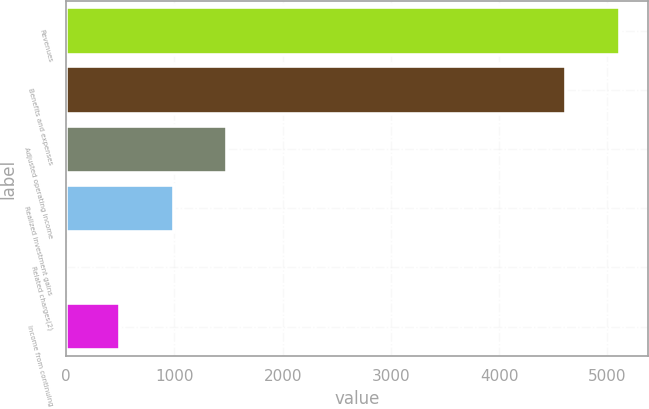Convert chart to OTSL. <chart><loc_0><loc_0><loc_500><loc_500><bar_chart><fcel>Revenues<fcel>Benefits and expenses<fcel>Adjusted operating income<fcel>Realized investment gains<fcel>Related charges(2)<fcel>Income from continuing<nl><fcel>5115.9<fcel>4620<fcel>1488.7<fcel>992.8<fcel>1<fcel>496.9<nl></chart> 